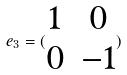<formula> <loc_0><loc_0><loc_500><loc_500>e _ { 3 } = ( \begin{matrix} 1 & 0 \\ 0 & - 1 \end{matrix} )</formula> 